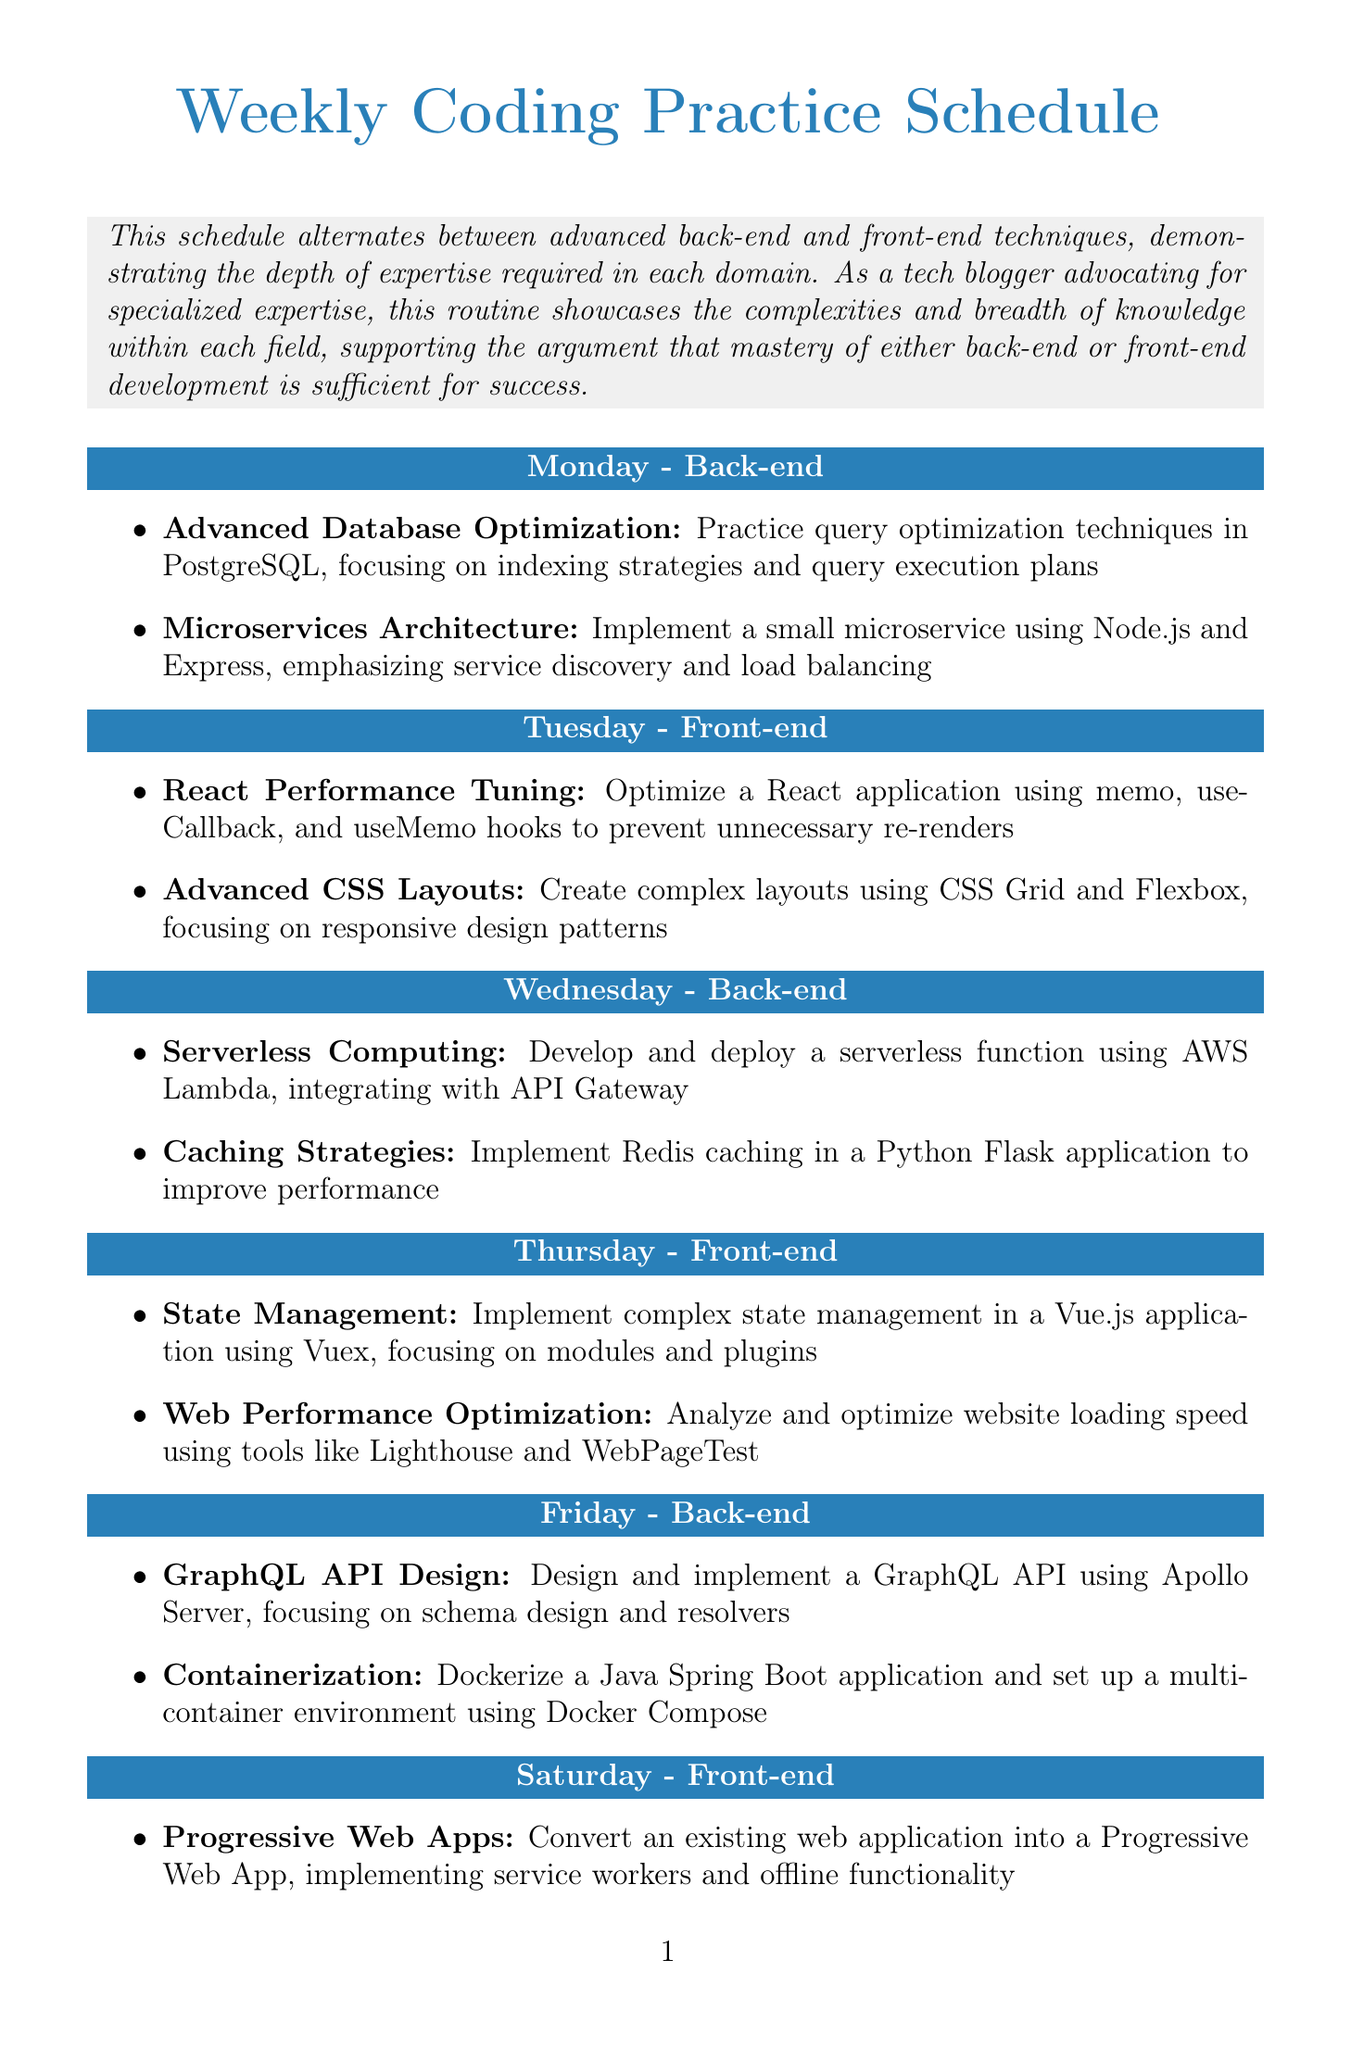What is the focus of Monday's schedule? The focus of Monday's schedule is labeled in the document as "Back-end."
Answer: Back-end How many activities are planned for each day? Each day features two activities listed within the document.
Answer: Two Which technique is practiced on Tuesday related to React? The specific activity listed for React on Tuesday is optimizing a React application.
Answer: React Performance Tuning What is the main purpose of the Sunday activities? The Sunday activities are focused on review and reflection of the week’s practice sessions.
Answer: Review and Reflection What architecture is emphasized during Wednesday's back-end activities? The architecture style mentioned for Wednesday is serverless computing, particularly with AWS Lambda.
Answer: Serverless Computing How many days focus on front-end development techniques? The document specifies that there are three days dedicated to front-end techniques.
Answer: Three What is the purpose of the Blog Post Creation activity on Sunday? The purpose is to write about learning experiences and the benefits of specialization in development.
Answer: Write a technical blog post Which caching solution is mentioned for Wednesday? The document refers to implementing Redis caching for performance improvement.
Answer: Redis What styling methods are highlighted on Tuesday for complex layouts? The methods discussed are CSS Grid and Flexbox for creating advanced layouts.
Answer: CSS Grid and Flexbox 